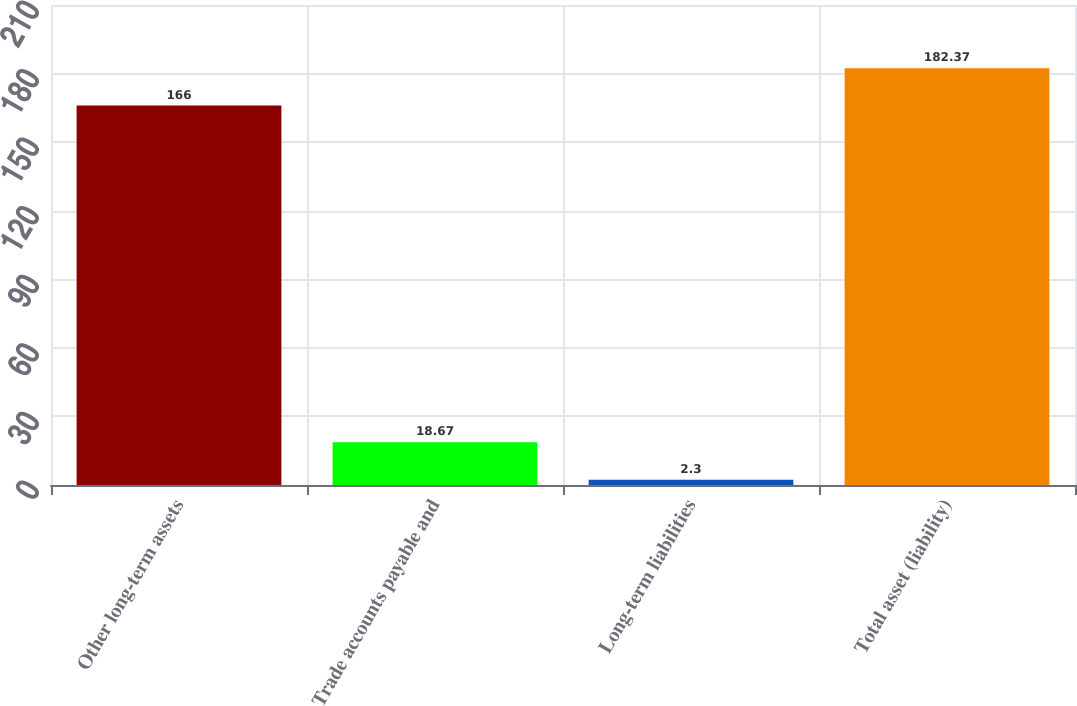<chart> <loc_0><loc_0><loc_500><loc_500><bar_chart><fcel>Other long-term assets<fcel>Trade accounts payable and<fcel>Long-term liabilities<fcel>Total asset (liability)<nl><fcel>166<fcel>18.67<fcel>2.3<fcel>182.37<nl></chart> 